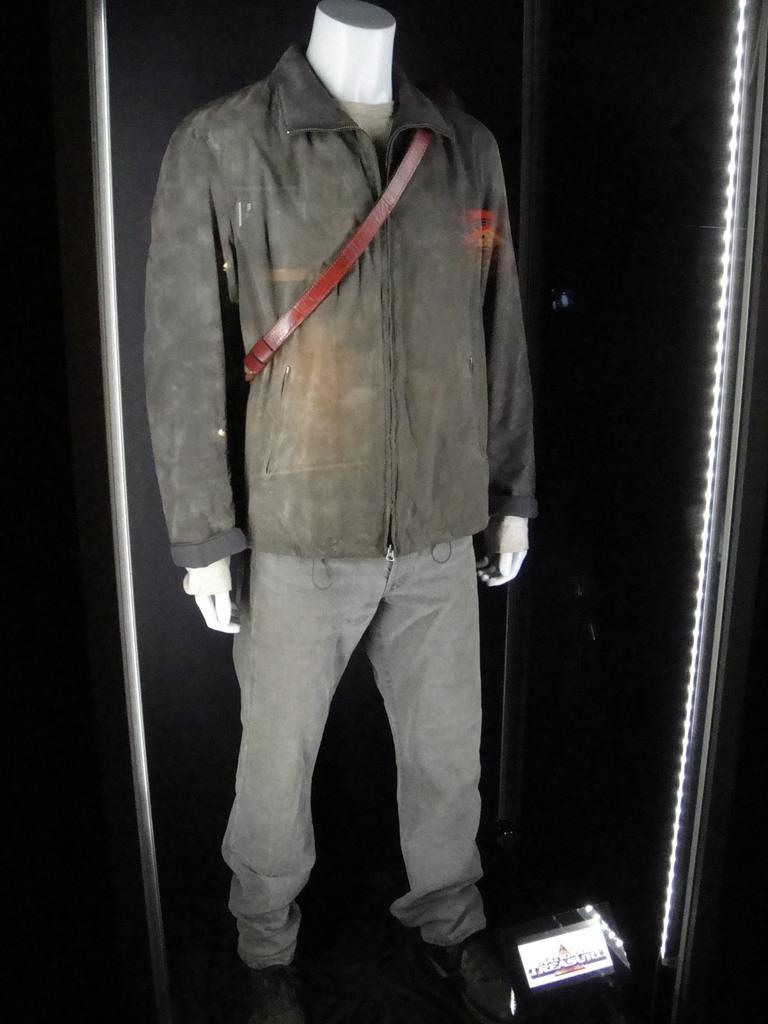What is the main subject in the image? There is a mannequin in the image. What type of clothing is the mannequin wearing? The mannequin is wearing male clothes. How many zebras can be seen playing basketball with the mannequin in the image? There are no zebras or basketballs present in the image; it only features a mannequin wearing male clothes. 